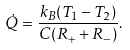<formula> <loc_0><loc_0><loc_500><loc_500>\dot { Q } = \frac { k _ { B } ( T _ { 1 } - T _ { 2 } ) } { C ( R _ { + } + R _ { - } ) } .</formula> 